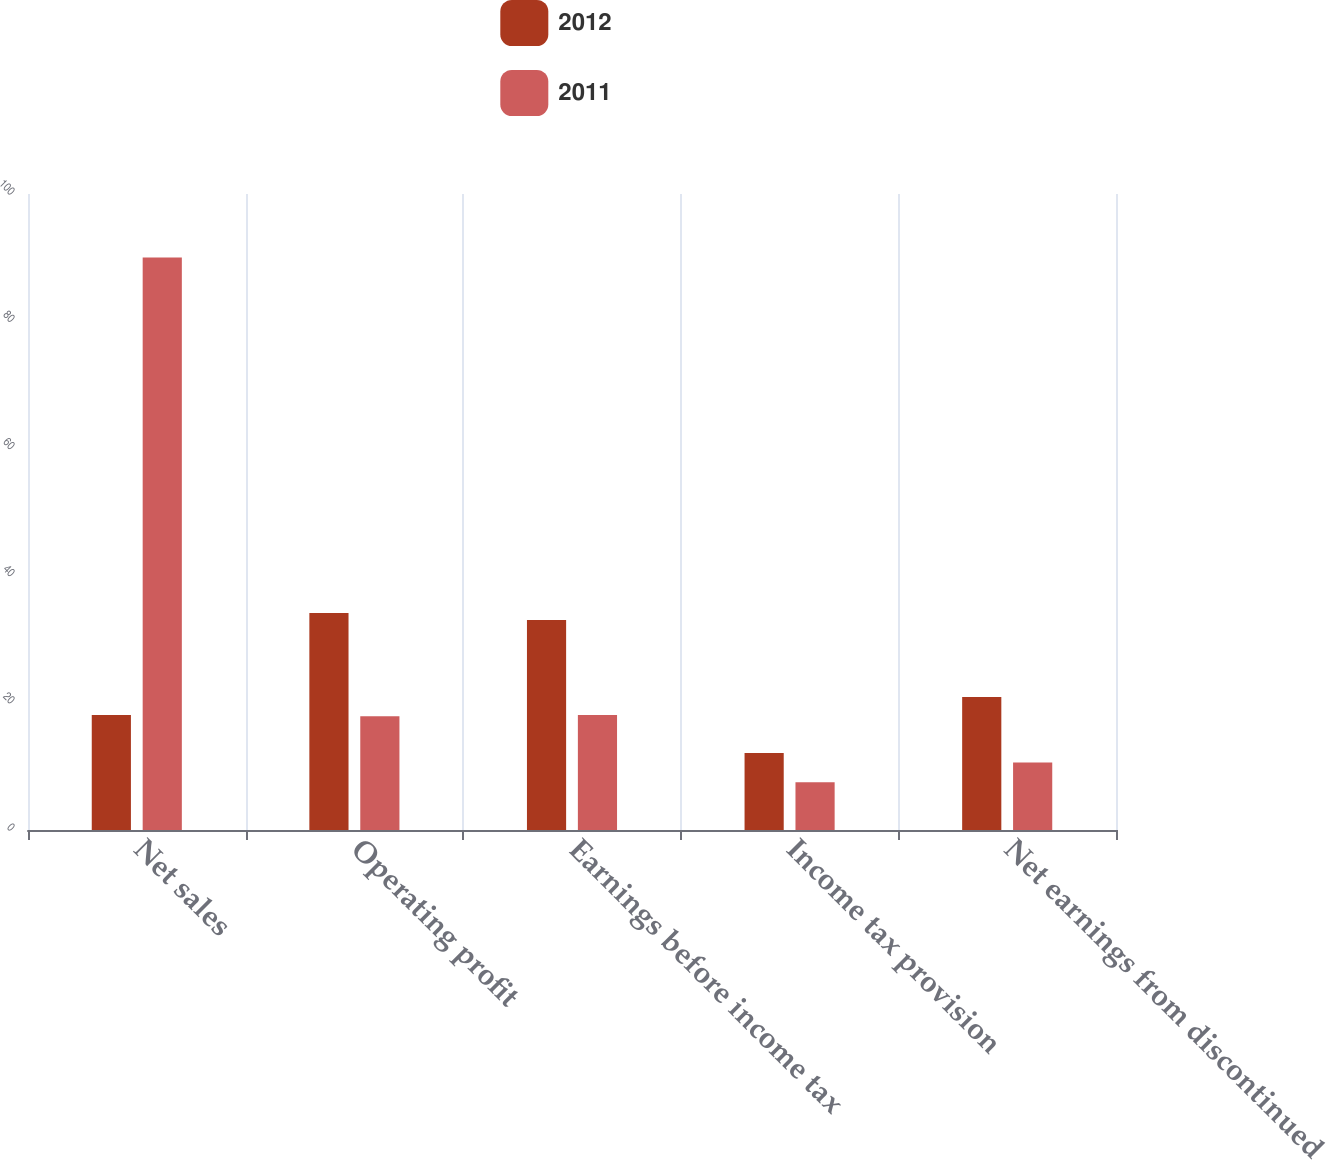Convert chart to OTSL. <chart><loc_0><loc_0><loc_500><loc_500><stacked_bar_chart><ecel><fcel>Net sales<fcel>Operating profit<fcel>Earnings before income tax<fcel>Income tax provision<fcel>Net earnings from discontinued<nl><fcel>2012<fcel>18.1<fcel>34.1<fcel>33<fcel>12.1<fcel>20.9<nl><fcel>2011<fcel>90<fcel>17.9<fcel>18.1<fcel>7.5<fcel>10.6<nl></chart> 